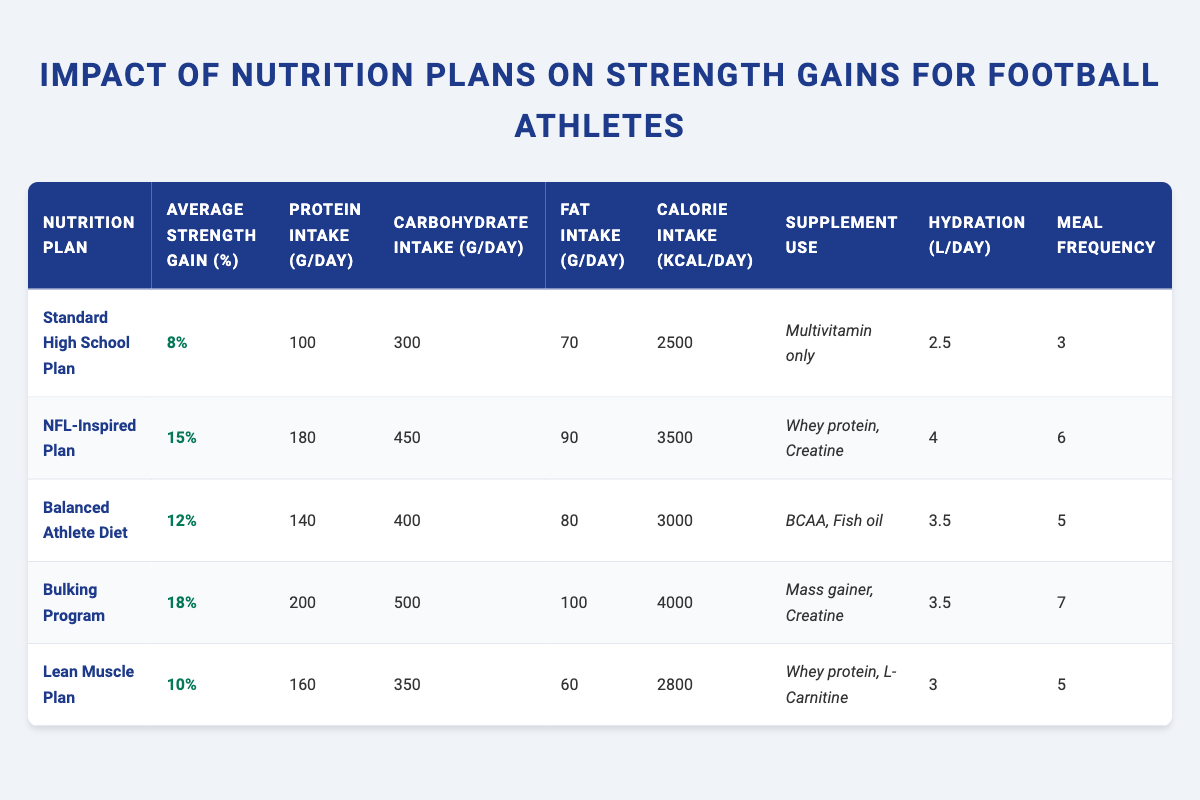What is the average strength gain for the Balanced Athlete Diet? From the table, the Balanced Athlete Diet shows an average strength gain of 12%.
Answer: 12% Which nutrition plan has the highest protein intake? The Bulking Program has the highest protein intake listed at 200 g/day.
Answer: 200 g/day What is the difference in average strength gain between the NFL-Inspired Plan and the Standard High School Plan? The NFL-Inspired Plan has an average strength gain of 15%, while the Standard High School Plan has 8%. The difference is 15% - 8% = 7%.
Answer: 7% Is the calorie intake for the Lean Muscle Plan higher than that of the Standard High School Plan? The Lean Muscle Plan has a calorie intake of 2800 kcal/day, while the Standard High School Plan has 2500 kcal/day. Since 2800 is greater than 2500, the statement is true.
Answer: Yes Which nutrition plan has the least meal frequency, and how many meals does it provide? The Standard High School Plan has the least meal frequency with 3 meals per day.
Answer: Standard High School Plan, 3 meals What is the average protein intake across all nutrition plans? To find the average protein intake, sum the protein intakes: 100 + 180 + 140 + 200 + 160 = 780 g/day. Divide by the number of plans (5), so 780/5 = 156 g/day.
Answer: 156 g/day Is the hydration level for the Bulking Program lower than that for the Lean Muscle Plan? The Bulking Program has a hydration level of 3.5 L/day, while the Lean Muscle Plan has 3 L/day, which means the Bulking Program is actually higher. So it is false.
Answer: No What is the average carbohydrate intake of the nutrition plans that include creatine as a supplement? The NFL-Inspired Plan and Bulking Program both include creatine. Their carbohydrate intakes are 450 g/day and 500 g/day, respectively. The average is (450 + 500) / 2 = 475 g/day.
Answer: 475 g/day 